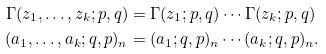Convert formula to latex. <formula><loc_0><loc_0><loc_500><loc_500>\Gamma ( z _ { 1 } , \dots , z _ { k } ; p , q ) & = \Gamma ( z _ { 1 } ; p , q ) \cdots \Gamma ( z _ { k } ; p , q ) \\ ( a _ { 1 } , \dots , a _ { k } ; q , p ) _ { n } & = ( a _ { 1 } ; q , p ) _ { n } \cdots ( a _ { k } ; q , p ) _ { n } .</formula> 